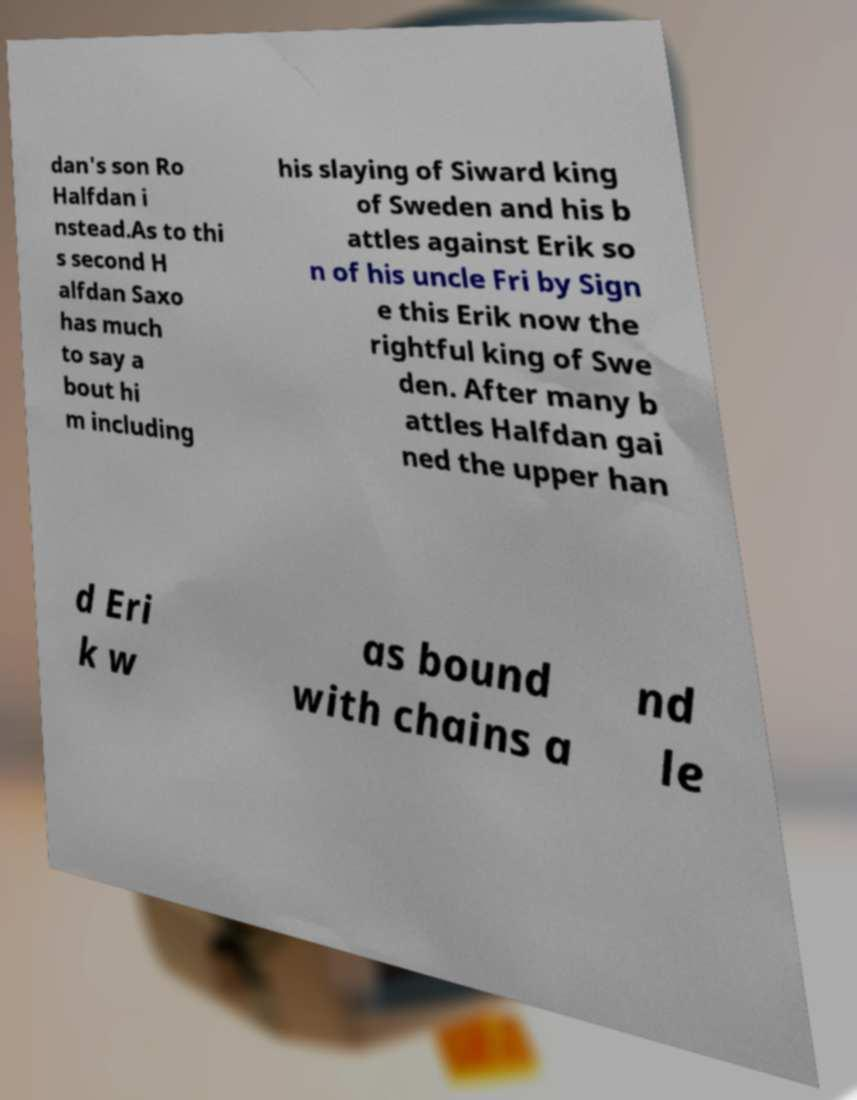For documentation purposes, I need the text within this image transcribed. Could you provide that? dan's son Ro Halfdan i nstead.As to thi s second H alfdan Saxo has much to say a bout hi m including his slaying of Siward king of Sweden and his b attles against Erik so n of his uncle Fri by Sign e this Erik now the rightful king of Swe den. After many b attles Halfdan gai ned the upper han d Eri k w as bound with chains a nd le 